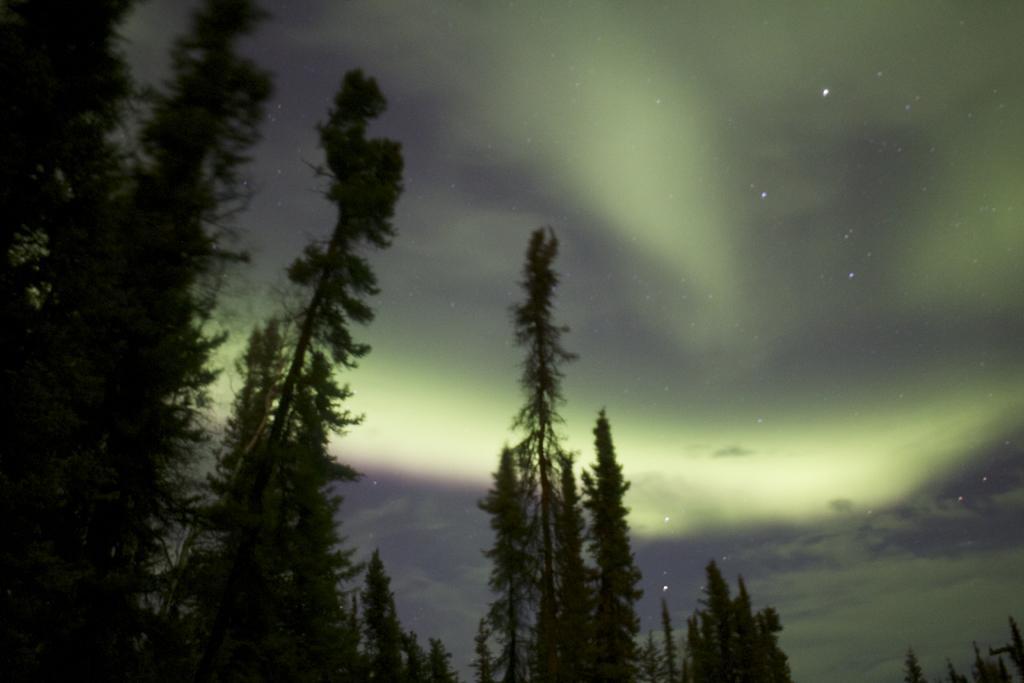Could you give a brief overview of what you see in this image? In this image there are few trees, there are stars and some clouds in the sky. 